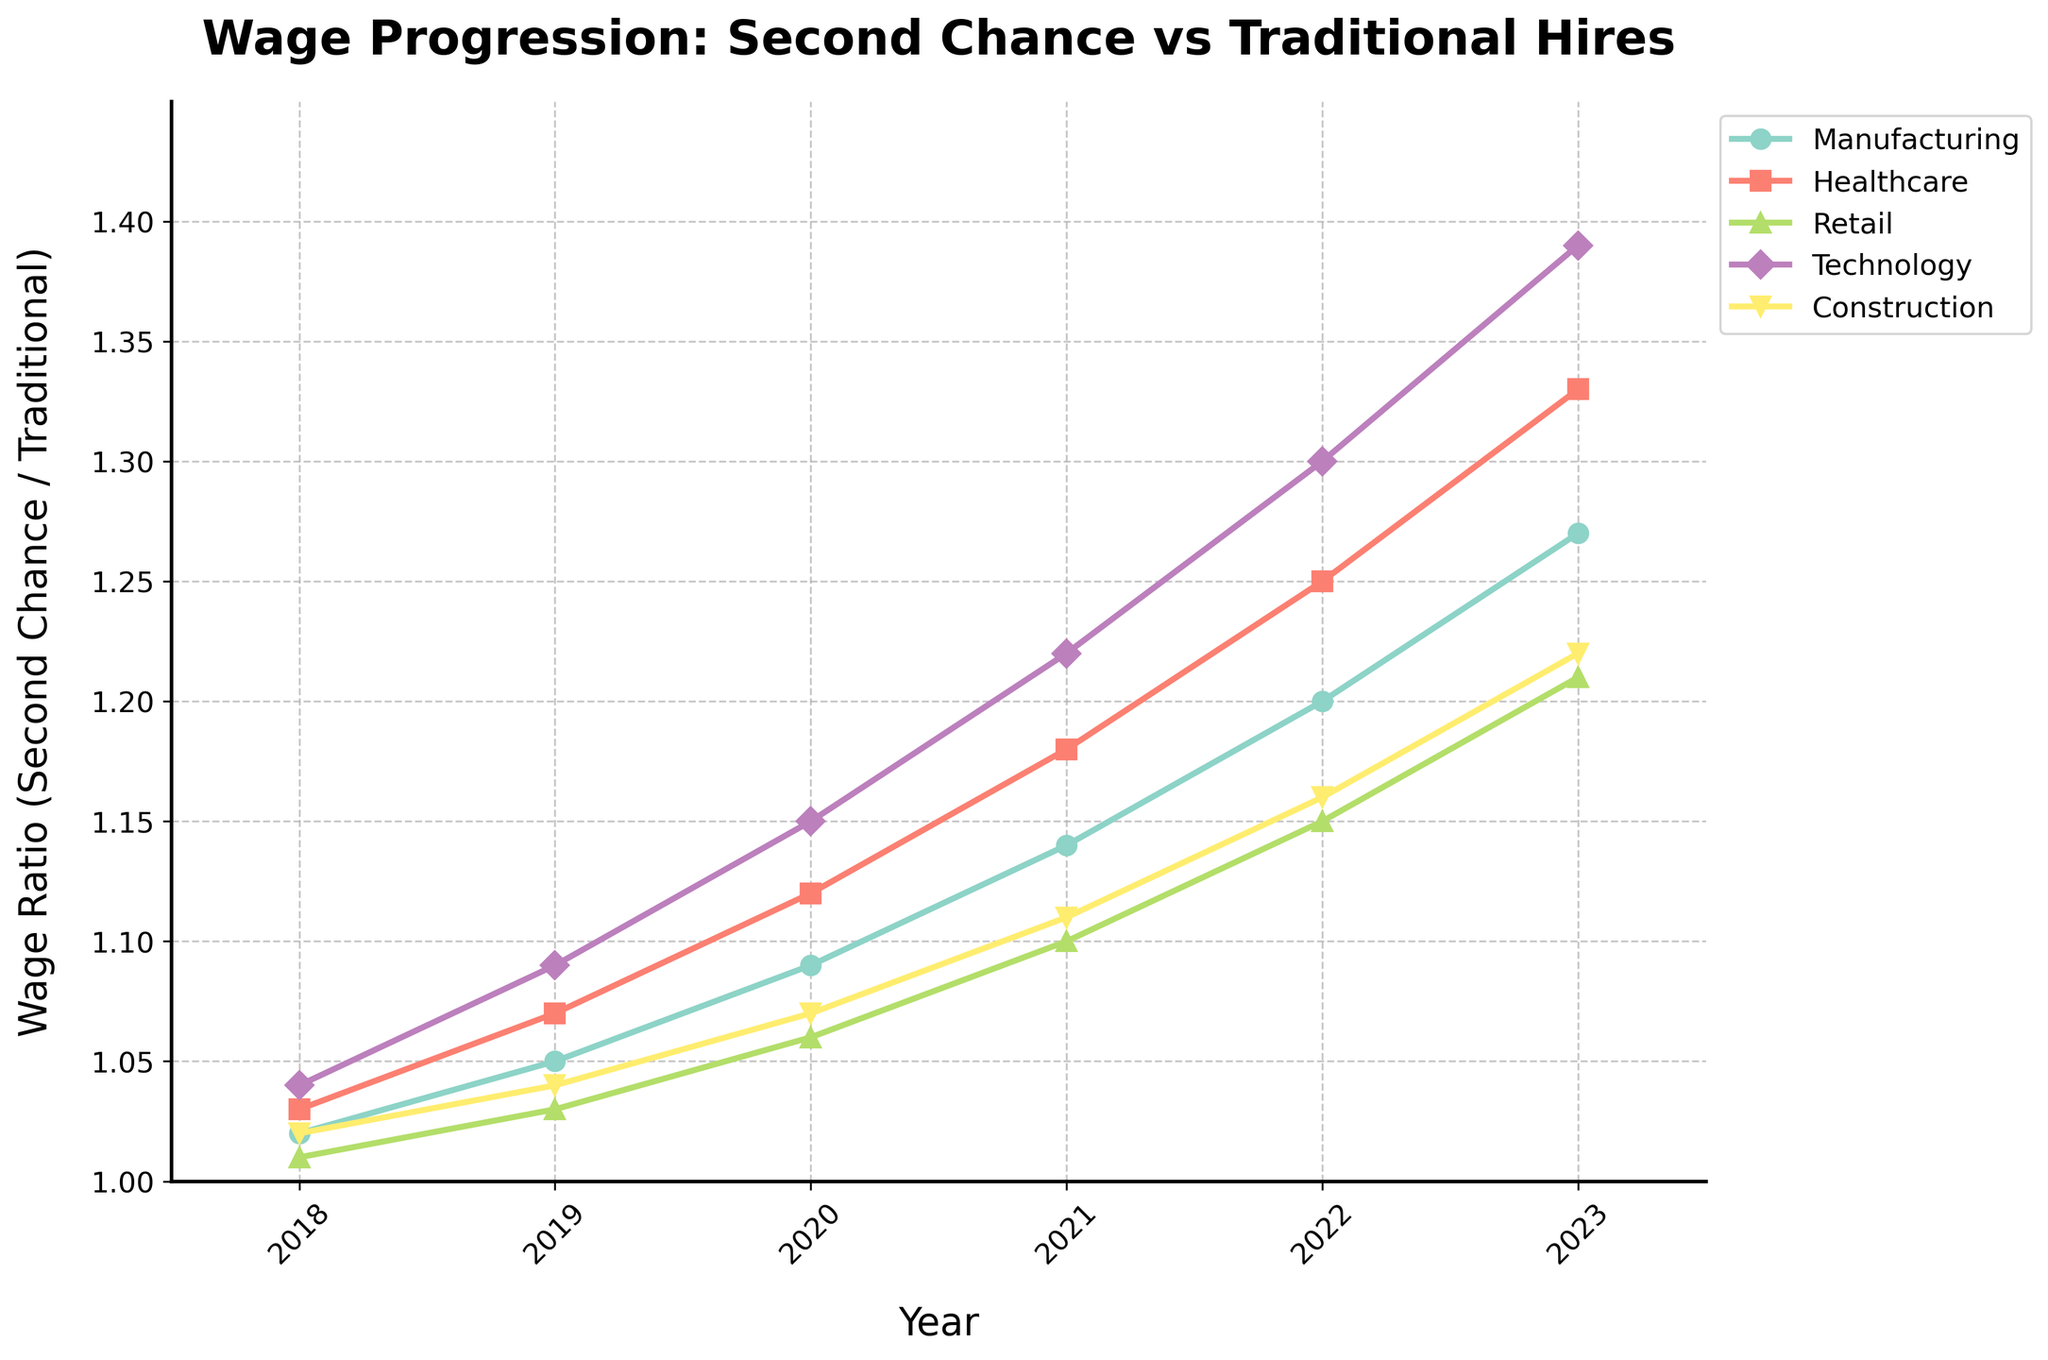What trend is observed for wage progression in the Technology industry from 2018 to 2023? By looking at the line representing the Technology industry, we can see a consistent upward trend. Starting from a wage ratio of 1.04 in 2018, it increases each year until it reaches 1.39 in 2023.
Answer: Consistent upward trend Which industry shows the highest wage ratio in 2023? To determine this, we compare the endpoints of each line for the year 2023. The Technology industry has the highest wage ratio at 1.39.
Answer: Technology How much did the wage ratio in the Healthcare industry increase from 2018 to 2022? The wage ratio for Healthcare in 2018 was 1.03 and increased to 1.25 in 2022. The difference is 1.25 - 1.03 = 0.22.
Answer: 0.22 Between 2020 and 2021, which industry had the largest increase in wage ratio? By comparing the differences in wage ratios between 2020 and 2021 for each industry, we observe: Manufacturing (1.14 - 1.09 = 0.05), Healthcare (1.18 - 1.12 = 0.06), Retail (1.10 - 1.06 = 0.04), Technology (1.22 - 1.15 = 0.07), and Construction (1.11 - 1.07 = 0.04). Technology shows the largest increase.
Answer: Technology What is the overall average wage ratio for the Retail industry from 2018 to 2023? First, we sum the wage ratios for Retail across the years: 1.01 + 1.03 + 1.06 + 1.10 + 1.15 + 1.21 = 6.56. Then, we divide by the number of years (6): 6.56 / 6 = 1.093.
Answer: 1.093 Which industry showed the smallest relative increase in wage ratio from 2018 to 2023? Calculating the relative increase for each industry: Manufacturing (1.27 - 1.02 = 0.25), Healthcare (1.33 - 1.03 = 0.30), Retail (1.21 - 1.01 = 0.20), Technology (1.39 - 1.04 = 0.35), Construction (1.22 - 1.02 = 0.20). Retail and Construction both have the smallest increase of 0.20.
Answer: Retail and Construction What can you say about the visual attribute of the Manufacturing industry's line compared to others? The Manufacturing industry's line is marked with 'o' shape markers and is one of the lower lines in terms of wage ratio, especially in the earlier years. Its color is a part of the Set3 color map, which appears to be yellowish-green in the chart.
Answer: Lower line with 'o' markers, yellowish-green Which two industries had almost identical wage ratios in 2020, and what were those ratios? By inspecting the lines for the year 2020, Construction and Healthcare both have close values around 1.12 for Healthcare and 1.07 for Construction. Upon precise observation, none are identical, but these two are relatively closer compared to others.
Answer: Healthcare: 1.12, Construction: 1.07 How many industries surpassed a wage ratio of 1.2 by 2023? Observing the endpoint of each line for 2023: Manufacturing (1.27), Healthcare (1.33), Retail (1.21), Technology (1.39), and Construction (1.22), we see all five industries surpassed the 1.2 mark.
Answer: 5 industries 